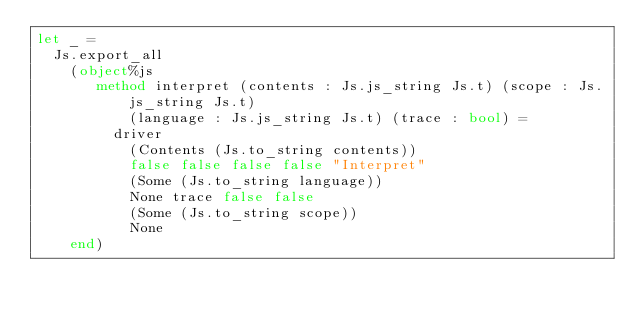Convert code to text. <code><loc_0><loc_0><loc_500><loc_500><_OCaml_>let _ =
  Js.export_all
    (object%js
       method interpret (contents : Js.js_string Js.t) (scope : Js.js_string Js.t)
           (language : Js.js_string Js.t) (trace : bool) =
         driver
           (Contents (Js.to_string contents))
           false false false false "Interpret"
           (Some (Js.to_string language))
           None trace false false
           (Some (Js.to_string scope))
           None
    end)
</code> 